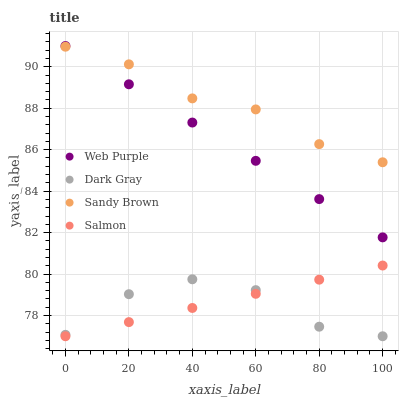Does Dark Gray have the minimum area under the curve?
Answer yes or no. Yes. Does Sandy Brown have the maximum area under the curve?
Answer yes or no. Yes. Does Salmon have the minimum area under the curve?
Answer yes or no. No. Does Salmon have the maximum area under the curve?
Answer yes or no. No. Is Salmon the smoothest?
Answer yes or no. Yes. Is Dark Gray the roughest?
Answer yes or no. Yes. Is Web Purple the smoothest?
Answer yes or no. No. Is Web Purple the roughest?
Answer yes or no. No. Does Dark Gray have the lowest value?
Answer yes or no. Yes. Does Web Purple have the lowest value?
Answer yes or no. No. Does Web Purple have the highest value?
Answer yes or no. Yes. Does Salmon have the highest value?
Answer yes or no. No. Is Dark Gray less than Web Purple?
Answer yes or no. Yes. Is Sandy Brown greater than Salmon?
Answer yes or no. Yes. Does Salmon intersect Dark Gray?
Answer yes or no. Yes. Is Salmon less than Dark Gray?
Answer yes or no. No. Is Salmon greater than Dark Gray?
Answer yes or no. No. Does Dark Gray intersect Web Purple?
Answer yes or no. No. 